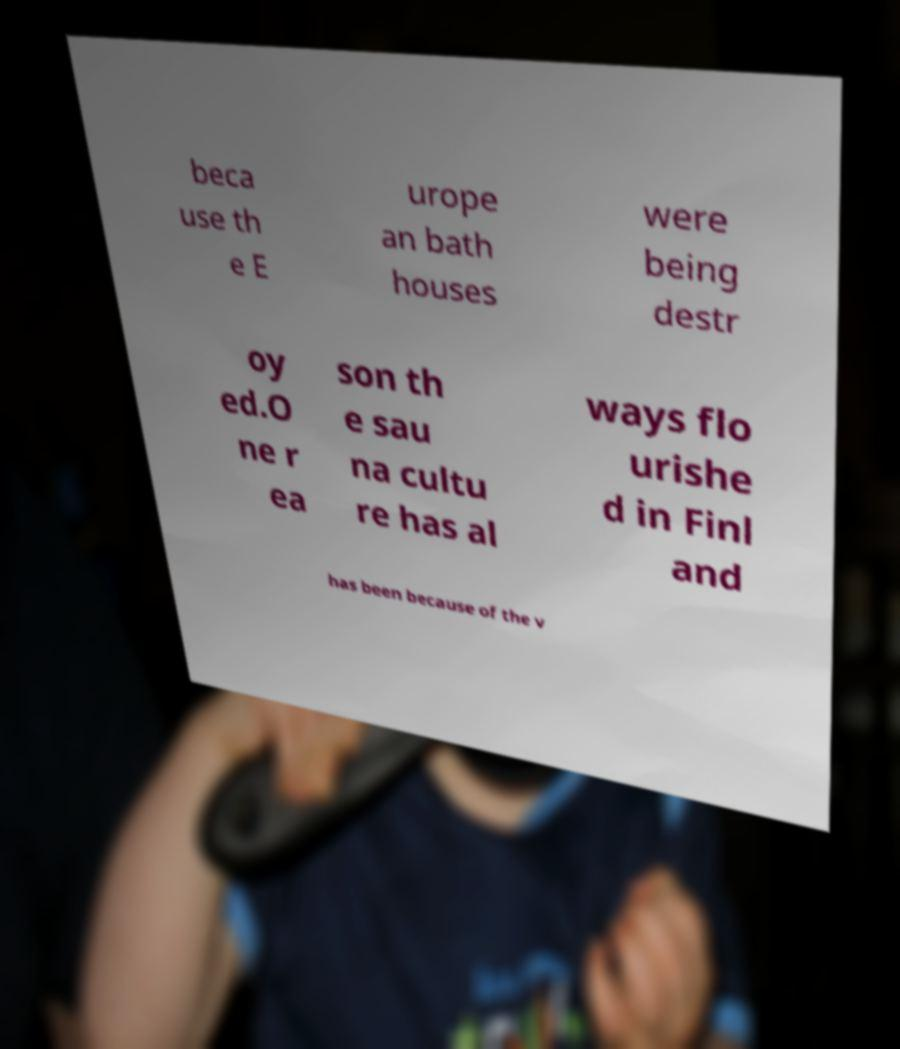Could you assist in decoding the text presented in this image and type it out clearly? beca use th e E urope an bath houses were being destr oy ed.O ne r ea son th e sau na cultu re has al ways flo urishe d in Finl and has been because of the v 